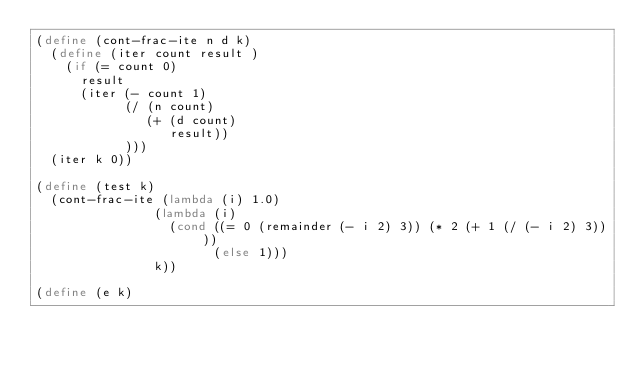Convert code to text. <code><loc_0><loc_0><loc_500><loc_500><_Scheme_>(define (cont-frac-ite n d k)
  (define (iter count result )
    (if (= count 0)
      result
      (iter (- count 1)
            (/ (n count)
               (+ (d count)
                  result))
            )))
  (iter k 0))

(define (test k)
  (cont-frac-ite (lambda (i) 1.0)
                (lambda (i)
                  (cond ((= 0 (remainder (- i 2) 3)) (* 2 (+ 1 (/ (- i 2) 3))))
                        (else 1)))
                k))

(define (e k)</code> 